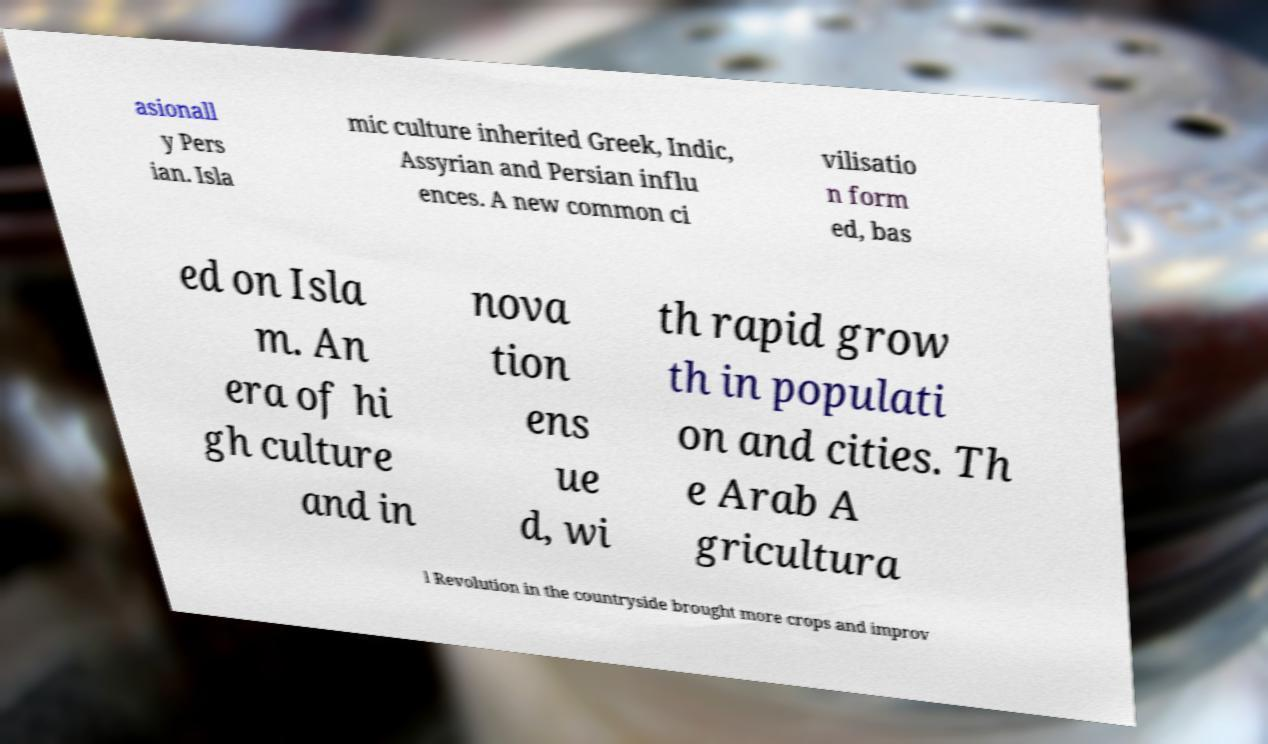Please identify and transcribe the text found in this image. asionall y Pers ian. Isla mic culture inherited Greek, Indic, Assyrian and Persian influ ences. A new common ci vilisatio n form ed, bas ed on Isla m. An era of hi gh culture and in nova tion ens ue d, wi th rapid grow th in populati on and cities. Th e Arab A gricultura l Revolution in the countryside brought more crops and improv 